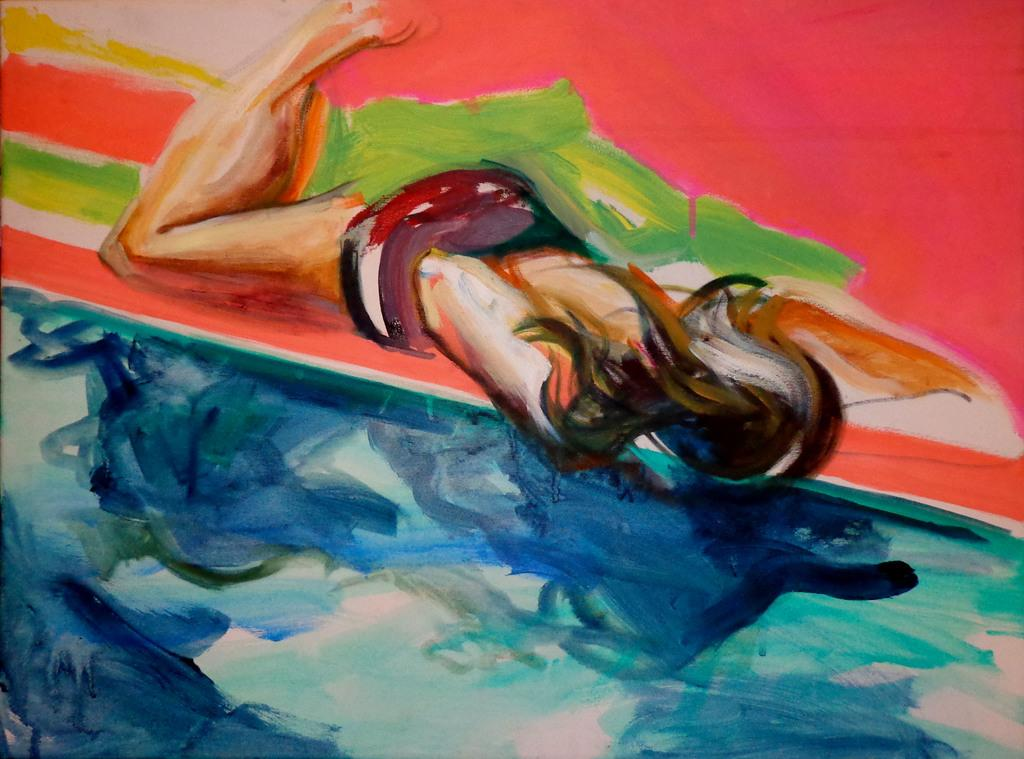What type of artwork is the image? The image is a painting. What is the main subject of the painting? The painting depicts a person. What type of trouble does the queen face in the painting? There is no queen present in the painting, so it is not possible to determine what type of trouble she might face. 